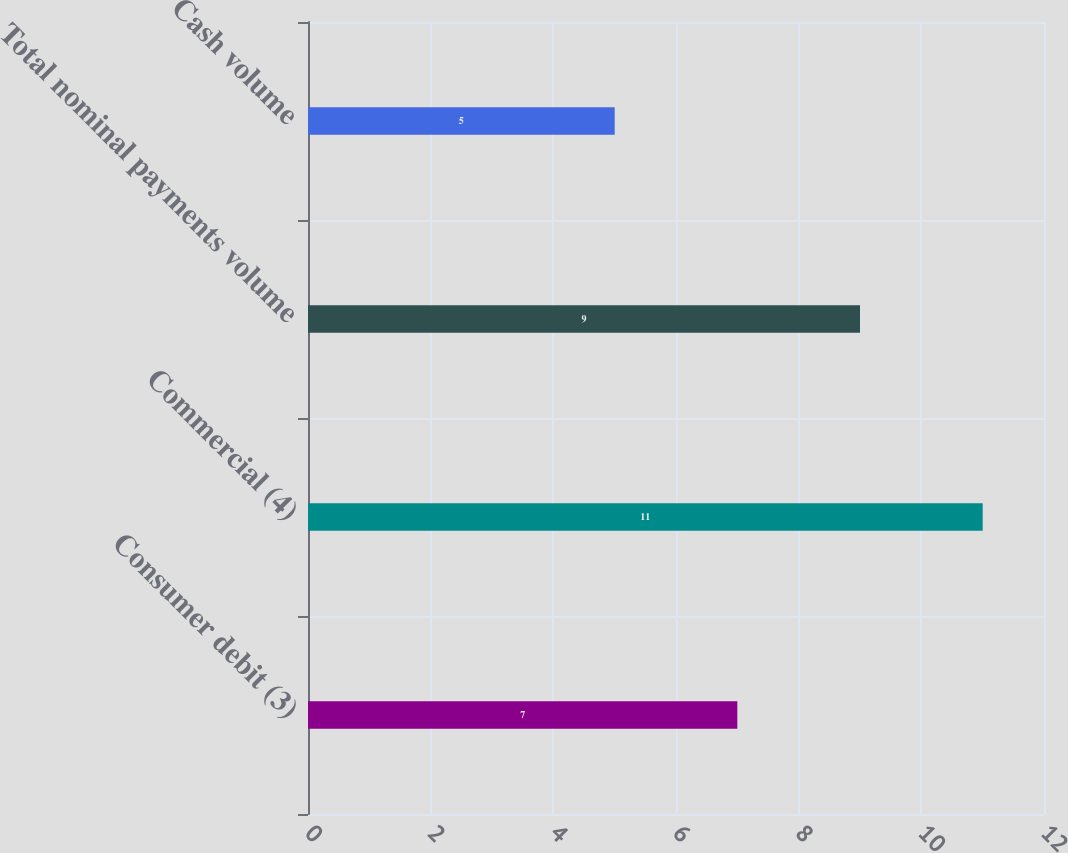<chart> <loc_0><loc_0><loc_500><loc_500><bar_chart><fcel>Consumer debit (3)<fcel>Commercial (4)<fcel>Total nominal payments volume<fcel>Cash volume<nl><fcel>7<fcel>11<fcel>9<fcel>5<nl></chart> 